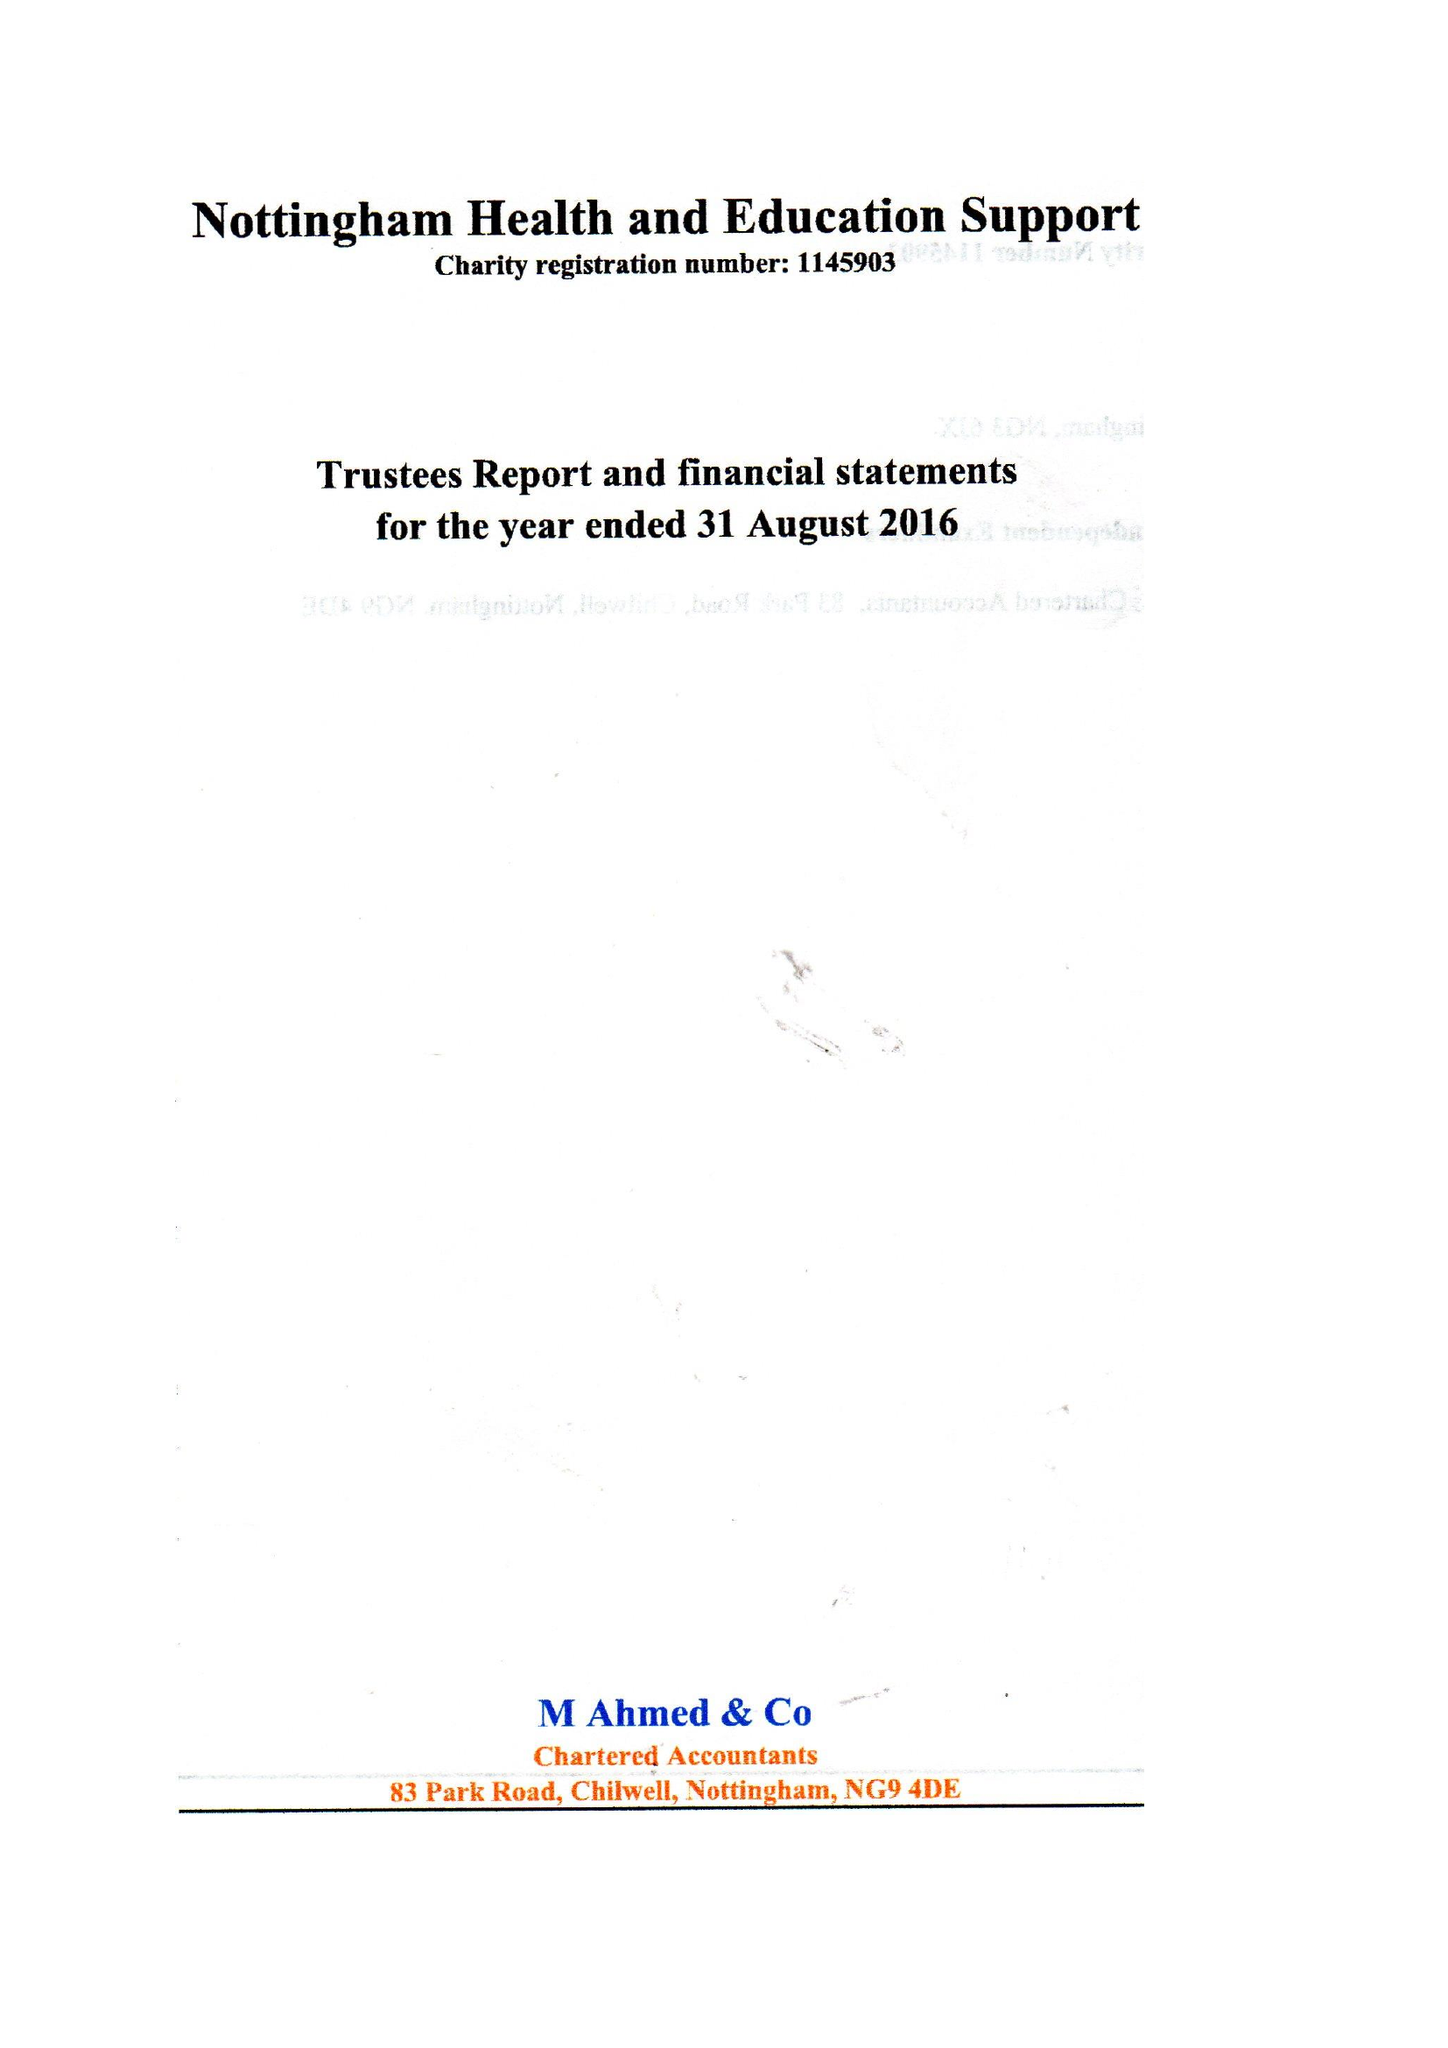What is the value for the charity_number?
Answer the question using a single word or phrase. 1145903 